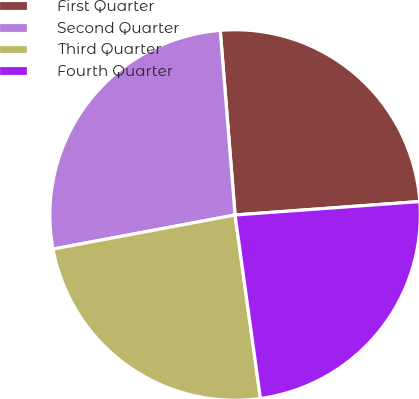Convert chart to OTSL. <chart><loc_0><loc_0><loc_500><loc_500><pie_chart><fcel>First Quarter<fcel>Second Quarter<fcel>Third Quarter<fcel>Fourth Quarter<nl><fcel>25.12%<fcel>26.67%<fcel>24.24%<fcel>23.97%<nl></chart> 